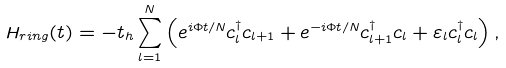Convert formula to latex. <formula><loc_0><loc_0><loc_500><loc_500>H _ { r i n g } ( t ) = - t _ { h } \sum _ { l = 1 } ^ { N } \left ( e ^ { i \Phi t / N } c ^ { \dagger } _ { l } c _ { l + 1 } + e ^ { - i \Phi t / N } c ^ { \dagger } _ { l + 1 } c _ { l } + \varepsilon _ { l } c ^ { \dagger } _ { l } c _ { l } \right ) ,</formula> 